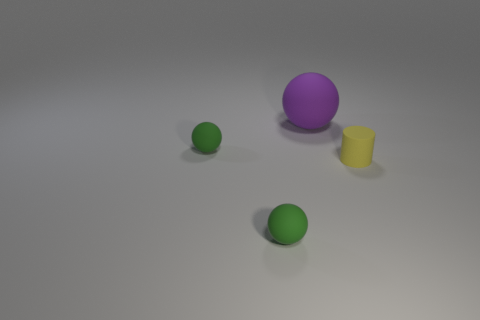How many things are either purple matte spheres left of the small yellow cylinder or objects that are on the right side of the large object?
Your response must be concise. 2. How many spheres are either big purple objects or tiny yellow matte things?
Your answer should be very brief. 1. How many small green balls are both in front of the yellow object and behind the cylinder?
Offer a very short reply. 0. There is a yellow matte cylinder; does it have the same size as the green thing that is behind the small rubber cylinder?
Provide a succinct answer. Yes. There is a small green ball that is in front of the tiny object that is on the right side of the big matte object; is there a object on the left side of it?
Your answer should be very brief. Yes. There is a small green object in front of the object that is on the right side of the big rubber object; what is it made of?
Provide a short and direct response. Rubber. There is a thing that is behind the tiny yellow matte cylinder and to the left of the big ball; what is it made of?
Keep it short and to the point. Rubber. Are there any green rubber things of the same shape as the big purple matte object?
Give a very brief answer. Yes. There is a green ball in front of the yellow object; is there a small rubber cylinder that is in front of it?
Ensure brevity in your answer.  No. What number of purple things are made of the same material as the small cylinder?
Keep it short and to the point. 1. 